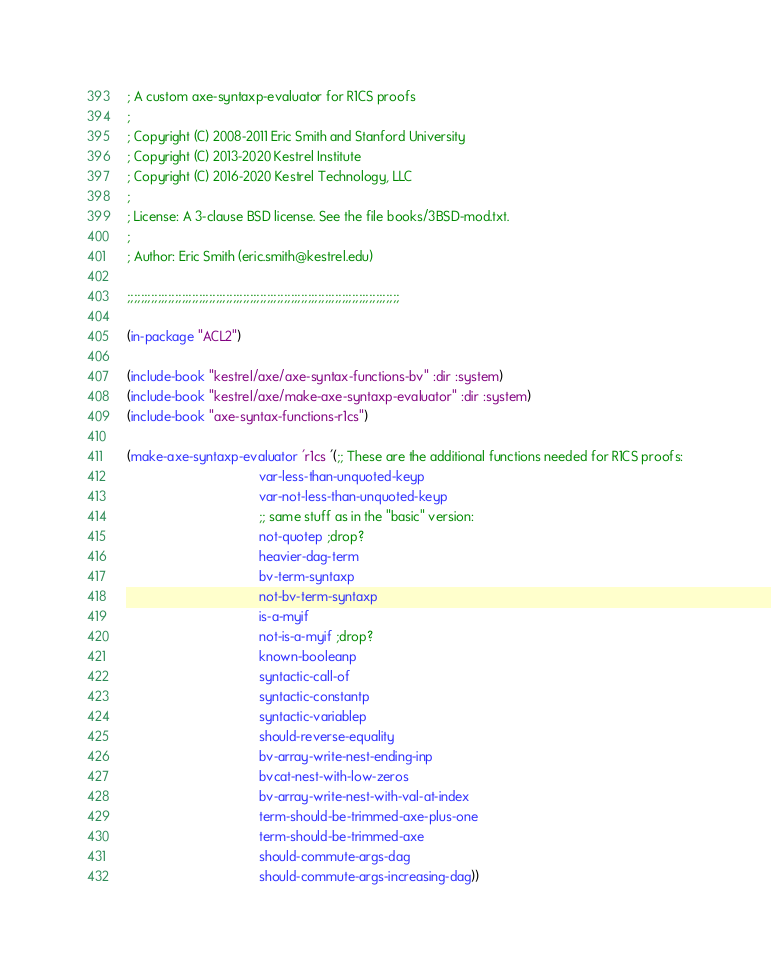<code> <loc_0><loc_0><loc_500><loc_500><_Lisp_>; A custom axe-syntaxp-evaluator for R1CS proofs
;
; Copyright (C) 2008-2011 Eric Smith and Stanford University
; Copyright (C) 2013-2020 Kestrel Institute
; Copyright (C) 2016-2020 Kestrel Technology, LLC
;
; License: A 3-clause BSD license. See the file books/3BSD-mod.txt.
;
; Author: Eric Smith (eric.smith@kestrel.edu)

;;;;;;;;;;;;;;;;;;;;;;;;;;;;;;;;;;;;;;;;;;;;;;;;;;;;;;;;;;;;;;;;;;;;;;;;;;;;;;;;

(in-package "ACL2")

(include-book "kestrel/axe/axe-syntax-functions-bv" :dir :system)
(include-book "kestrel/axe/make-axe-syntaxp-evaluator" :dir :system)
(include-book "axe-syntax-functions-r1cs")

(make-axe-syntaxp-evaluator 'r1cs '(;; These are the additional functions needed for R1CS proofs:
                                    var-less-than-unquoted-keyp
                                    var-not-less-than-unquoted-keyp
                                    ;; same stuff as in the "basic" version:
                                    not-quotep ;drop?
                                    heavier-dag-term
                                    bv-term-syntaxp
                                    not-bv-term-syntaxp
                                    is-a-myif
                                    not-is-a-myif ;drop?
                                    known-booleanp
                                    syntactic-call-of
                                    syntactic-constantp
                                    syntactic-variablep
                                    should-reverse-equality
                                    bv-array-write-nest-ending-inp
                                    bvcat-nest-with-low-zeros
                                    bv-array-write-nest-with-val-at-index
                                    term-should-be-trimmed-axe-plus-one
                                    term-should-be-trimmed-axe
                                    should-commute-args-dag
                                    should-commute-args-increasing-dag))
</code> 